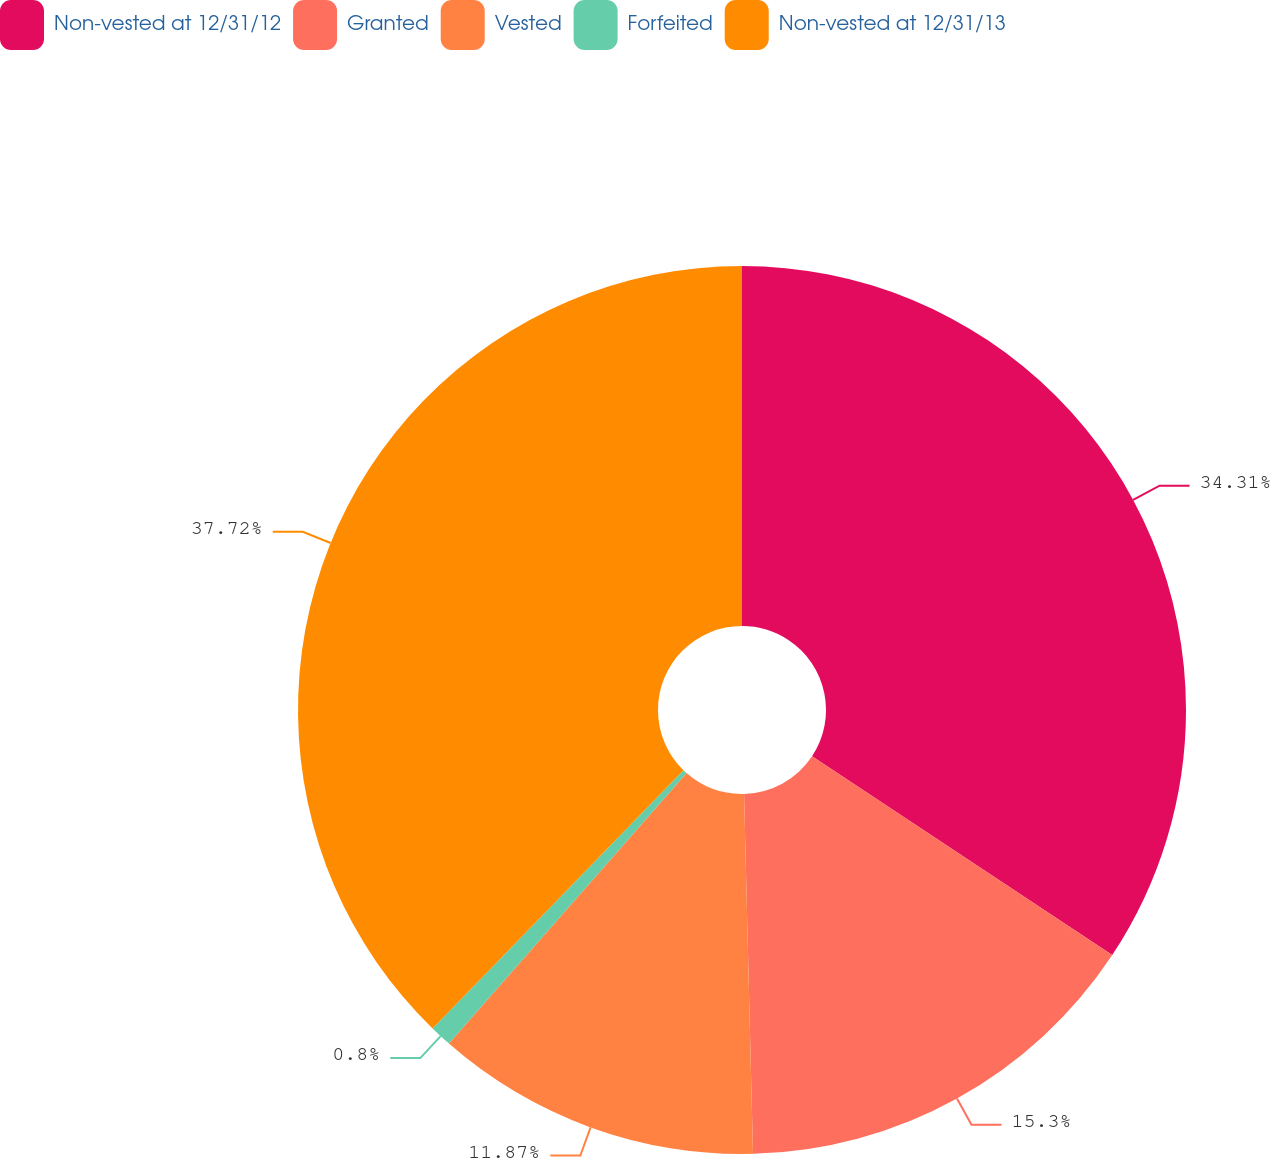<chart> <loc_0><loc_0><loc_500><loc_500><pie_chart><fcel>Non-vested at 12/31/12<fcel>Granted<fcel>Vested<fcel>Forfeited<fcel>Non-vested at 12/31/13<nl><fcel>34.31%<fcel>15.3%<fcel>11.87%<fcel>0.8%<fcel>37.73%<nl></chart> 